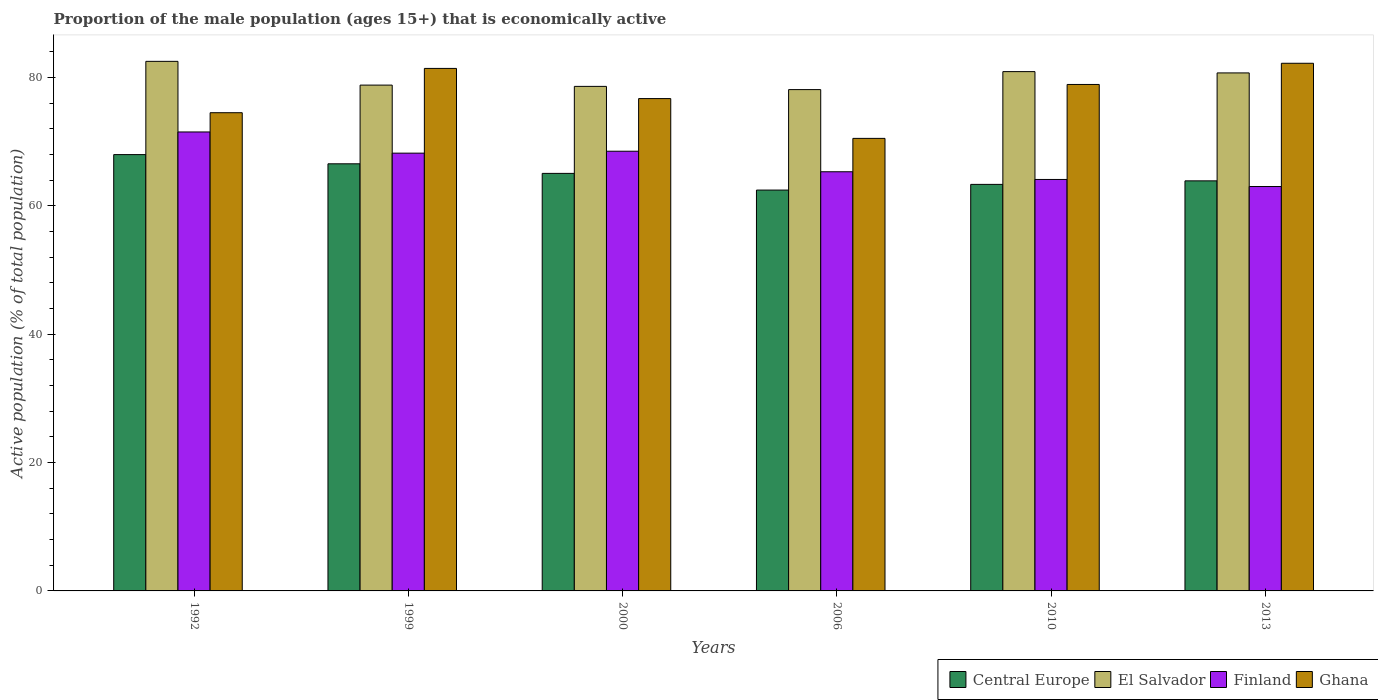How many different coloured bars are there?
Give a very brief answer. 4. How many bars are there on the 1st tick from the left?
Provide a succinct answer. 4. How many bars are there on the 5th tick from the right?
Offer a very short reply. 4. In how many cases, is the number of bars for a given year not equal to the number of legend labels?
Your answer should be very brief. 0. What is the proportion of the male population that is economically active in Central Europe in 1999?
Offer a terse response. 66.54. Across all years, what is the maximum proportion of the male population that is economically active in Finland?
Ensure brevity in your answer.  71.5. In which year was the proportion of the male population that is economically active in El Salvador maximum?
Your response must be concise. 1992. In which year was the proportion of the male population that is economically active in El Salvador minimum?
Make the answer very short. 2006. What is the total proportion of the male population that is economically active in Central Europe in the graph?
Provide a short and direct response. 389.22. What is the difference between the proportion of the male population that is economically active in El Salvador in 1992 and that in 1999?
Make the answer very short. 3.7. What is the difference between the proportion of the male population that is economically active in Finland in 2000 and the proportion of the male population that is economically active in El Salvador in 2013?
Give a very brief answer. -12.2. What is the average proportion of the male population that is economically active in Central Europe per year?
Make the answer very short. 64.87. In the year 2006, what is the difference between the proportion of the male population that is economically active in Ghana and proportion of the male population that is economically active in Finland?
Keep it short and to the point. 5.2. In how many years, is the proportion of the male population that is economically active in El Salvador greater than 12 %?
Your answer should be very brief. 6. What is the ratio of the proportion of the male population that is economically active in El Salvador in 2010 to that in 2013?
Keep it short and to the point. 1. Is the difference between the proportion of the male population that is economically active in Ghana in 1992 and 1999 greater than the difference between the proportion of the male population that is economically active in Finland in 1992 and 1999?
Make the answer very short. No. What is the difference between the highest and the second highest proportion of the male population that is economically active in El Salvador?
Your response must be concise. 1.6. What is the difference between the highest and the lowest proportion of the male population that is economically active in Central Europe?
Keep it short and to the point. 5.53. In how many years, is the proportion of the male population that is economically active in Ghana greater than the average proportion of the male population that is economically active in Ghana taken over all years?
Your response must be concise. 3. Is the sum of the proportion of the male population that is economically active in Ghana in 1999 and 2006 greater than the maximum proportion of the male population that is economically active in Central Europe across all years?
Provide a succinct answer. Yes. What does the 3rd bar from the right in 2010 represents?
Make the answer very short. El Salvador. Is it the case that in every year, the sum of the proportion of the male population that is economically active in Central Europe and proportion of the male population that is economically active in Ghana is greater than the proportion of the male population that is economically active in El Salvador?
Ensure brevity in your answer.  Yes. How many bars are there?
Your answer should be very brief. 24. Are all the bars in the graph horizontal?
Your answer should be compact. No. How many years are there in the graph?
Offer a terse response. 6. Does the graph contain any zero values?
Provide a succinct answer. No. Where does the legend appear in the graph?
Your answer should be very brief. Bottom right. How are the legend labels stacked?
Offer a terse response. Horizontal. What is the title of the graph?
Your response must be concise. Proportion of the male population (ages 15+) that is economically active. Does "Samoa" appear as one of the legend labels in the graph?
Your response must be concise. No. What is the label or title of the Y-axis?
Your answer should be compact. Active population (% of total population). What is the Active population (% of total population) of Central Europe in 1992?
Your answer should be compact. 67.97. What is the Active population (% of total population) of El Salvador in 1992?
Provide a succinct answer. 82.5. What is the Active population (% of total population) of Finland in 1992?
Offer a terse response. 71.5. What is the Active population (% of total population) of Ghana in 1992?
Give a very brief answer. 74.5. What is the Active population (% of total population) of Central Europe in 1999?
Offer a very short reply. 66.54. What is the Active population (% of total population) in El Salvador in 1999?
Keep it short and to the point. 78.8. What is the Active population (% of total population) in Finland in 1999?
Keep it short and to the point. 68.2. What is the Active population (% of total population) in Ghana in 1999?
Offer a terse response. 81.4. What is the Active population (% of total population) of Central Europe in 2000?
Provide a short and direct response. 65.05. What is the Active population (% of total population) in El Salvador in 2000?
Your answer should be very brief. 78.6. What is the Active population (% of total population) in Finland in 2000?
Your answer should be very brief. 68.5. What is the Active population (% of total population) of Ghana in 2000?
Offer a terse response. 76.7. What is the Active population (% of total population) in Central Europe in 2006?
Your response must be concise. 62.45. What is the Active population (% of total population) in El Salvador in 2006?
Keep it short and to the point. 78.1. What is the Active population (% of total population) in Finland in 2006?
Give a very brief answer. 65.3. What is the Active population (% of total population) of Ghana in 2006?
Keep it short and to the point. 70.5. What is the Active population (% of total population) of Central Europe in 2010?
Provide a succinct answer. 63.33. What is the Active population (% of total population) of El Salvador in 2010?
Make the answer very short. 80.9. What is the Active population (% of total population) in Finland in 2010?
Your answer should be compact. 64.1. What is the Active population (% of total population) of Ghana in 2010?
Your response must be concise. 78.9. What is the Active population (% of total population) in Central Europe in 2013?
Offer a terse response. 63.88. What is the Active population (% of total population) in El Salvador in 2013?
Offer a very short reply. 80.7. What is the Active population (% of total population) in Ghana in 2013?
Give a very brief answer. 82.2. Across all years, what is the maximum Active population (% of total population) of Central Europe?
Your answer should be compact. 67.97. Across all years, what is the maximum Active population (% of total population) in El Salvador?
Provide a short and direct response. 82.5. Across all years, what is the maximum Active population (% of total population) in Finland?
Provide a succinct answer. 71.5. Across all years, what is the maximum Active population (% of total population) in Ghana?
Make the answer very short. 82.2. Across all years, what is the minimum Active population (% of total population) of Central Europe?
Give a very brief answer. 62.45. Across all years, what is the minimum Active population (% of total population) of El Salvador?
Your response must be concise. 78.1. Across all years, what is the minimum Active population (% of total population) in Finland?
Offer a very short reply. 63. Across all years, what is the minimum Active population (% of total population) in Ghana?
Your answer should be very brief. 70.5. What is the total Active population (% of total population) of Central Europe in the graph?
Provide a short and direct response. 389.22. What is the total Active population (% of total population) in El Salvador in the graph?
Provide a short and direct response. 479.6. What is the total Active population (% of total population) of Finland in the graph?
Your answer should be very brief. 400.6. What is the total Active population (% of total population) of Ghana in the graph?
Provide a short and direct response. 464.2. What is the difference between the Active population (% of total population) in Central Europe in 1992 and that in 1999?
Provide a short and direct response. 1.43. What is the difference between the Active population (% of total population) in El Salvador in 1992 and that in 1999?
Provide a short and direct response. 3.7. What is the difference between the Active population (% of total population) of Ghana in 1992 and that in 1999?
Your answer should be compact. -6.9. What is the difference between the Active population (% of total population) in Central Europe in 1992 and that in 2000?
Offer a very short reply. 2.93. What is the difference between the Active population (% of total population) in El Salvador in 1992 and that in 2000?
Offer a terse response. 3.9. What is the difference between the Active population (% of total population) of Finland in 1992 and that in 2000?
Provide a short and direct response. 3. What is the difference between the Active population (% of total population) in Central Europe in 1992 and that in 2006?
Offer a terse response. 5.53. What is the difference between the Active population (% of total population) in El Salvador in 1992 and that in 2006?
Keep it short and to the point. 4.4. What is the difference between the Active population (% of total population) in Ghana in 1992 and that in 2006?
Keep it short and to the point. 4. What is the difference between the Active population (% of total population) in Central Europe in 1992 and that in 2010?
Keep it short and to the point. 4.64. What is the difference between the Active population (% of total population) in El Salvador in 1992 and that in 2010?
Make the answer very short. 1.6. What is the difference between the Active population (% of total population) in Finland in 1992 and that in 2010?
Offer a terse response. 7.4. What is the difference between the Active population (% of total population) of Ghana in 1992 and that in 2010?
Provide a short and direct response. -4.4. What is the difference between the Active population (% of total population) of Central Europe in 1992 and that in 2013?
Offer a terse response. 4.09. What is the difference between the Active population (% of total population) in El Salvador in 1992 and that in 2013?
Your response must be concise. 1.8. What is the difference between the Active population (% of total population) of Ghana in 1992 and that in 2013?
Provide a short and direct response. -7.7. What is the difference between the Active population (% of total population) of Central Europe in 1999 and that in 2000?
Keep it short and to the point. 1.49. What is the difference between the Active population (% of total population) of Finland in 1999 and that in 2000?
Give a very brief answer. -0.3. What is the difference between the Active population (% of total population) in Ghana in 1999 and that in 2000?
Ensure brevity in your answer.  4.7. What is the difference between the Active population (% of total population) of Central Europe in 1999 and that in 2006?
Make the answer very short. 4.09. What is the difference between the Active population (% of total population) in El Salvador in 1999 and that in 2006?
Provide a succinct answer. 0.7. What is the difference between the Active population (% of total population) of Finland in 1999 and that in 2006?
Ensure brevity in your answer.  2.9. What is the difference between the Active population (% of total population) in Ghana in 1999 and that in 2006?
Provide a succinct answer. 10.9. What is the difference between the Active population (% of total population) of Central Europe in 1999 and that in 2010?
Keep it short and to the point. 3.21. What is the difference between the Active population (% of total population) of El Salvador in 1999 and that in 2010?
Offer a terse response. -2.1. What is the difference between the Active population (% of total population) in Finland in 1999 and that in 2010?
Keep it short and to the point. 4.1. What is the difference between the Active population (% of total population) in Ghana in 1999 and that in 2010?
Your answer should be very brief. 2.5. What is the difference between the Active population (% of total population) of Central Europe in 1999 and that in 2013?
Keep it short and to the point. 2.66. What is the difference between the Active population (% of total population) of El Salvador in 1999 and that in 2013?
Offer a terse response. -1.9. What is the difference between the Active population (% of total population) of Ghana in 1999 and that in 2013?
Give a very brief answer. -0.8. What is the difference between the Active population (% of total population) in Central Europe in 2000 and that in 2006?
Your answer should be very brief. 2.6. What is the difference between the Active population (% of total population) of El Salvador in 2000 and that in 2006?
Your response must be concise. 0.5. What is the difference between the Active population (% of total population) in Central Europe in 2000 and that in 2010?
Your response must be concise. 1.71. What is the difference between the Active population (% of total population) of El Salvador in 2000 and that in 2010?
Provide a succinct answer. -2.3. What is the difference between the Active population (% of total population) of Central Europe in 2000 and that in 2013?
Ensure brevity in your answer.  1.16. What is the difference between the Active population (% of total population) in El Salvador in 2000 and that in 2013?
Make the answer very short. -2.1. What is the difference between the Active population (% of total population) in Ghana in 2000 and that in 2013?
Provide a succinct answer. -5.5. What is the difference between the Active population (% of total population) in Central Europe in 2006 and that in 2010?
Offer a very short reply. -0.89. What is the difference between the Active population (% of total population) in Central Europe in 2006 and that in 2013?
Ensure brevity in your answer.  -1.44. What is the difference between the Active population (% of total population) in Ghana in 2006 and that in 2013?
Offer a terse response. -11.7. What is the difference between the Active population (% of total population) of Central Europe in 2010 and that in 2013?
Make the answer very short. -0.55. What is the difference between the Active population (% of total population) of El Salvador in 2010 and that in 2013?
Give a very brief answer. 0.2. What is the difference between the Active population (% of total population) of Finland in 2010 and that in 2013?
Provide a succinct answer. 1.1. What is the difference between the Active population (% of total population) of Ghana in 2010 and that in 2013?
Offer a very short reply. -3.3. What is the difference between the Active population (% of total population) in Central Europe in 1992 and the Active population (% of total population) in El Salvador in 1999?
Offer a terse response. -10.83. What is the difference between the Active population (% of total population) in Central Europe in 1992 and the Active population (% of total population) in Finland in 1999?
Your response must be concise. -0.23. What is the difference between the Active population (% of total population) of Central Europe in 1992 and the Active population (% of total population) of Ghana in 1999?
Your answer should be very brief. -13.43. What is the difference between the Active population (% of total population) of El Salvador in 1992 and the Active population (% of total population) of Finland in 1999?
Ensure brevity in your answer.  14.3. What is the difference between the Active population (% of total population) in Finland in 1992 and the Active population (% of total population) in Ghana in 1999?
Provide a succinct answer. -9.9. What is the difference between the Active population (% of total population) of Central Europe in 1992 and the Active population (% of total population) of El Salvador in 2000?
Provide a succinct answer. -10.63. What is the difference between the Active population (% of total population) in Central Europe in 1992 and the Active population (% of total population) in Finland in 2000?
Your answer should be very brief. -0.53. What is the difference between the Active population (% of total population) of Central Europe in 1992 and the Active population (% of total population) of Ghana in 2000?
Ensure brevity in your answer.  -8.73. What is the difference between the Active population (% of total population) of Finland in 1992 and the Active population (% of total population) of Ghana in 2000?
Offer a terse response. -5.2. What is the difference between the Active population (% of total population) of Central Europe in 1992 and the Active population (% of total population) of El Salvador in 2006?
Offer a terse response. -10.13. What is the difference between the Active population (% of total population) of Central Europe in 1992 and the Active population (% of total population) of Finland in 2006?
Keep it short and to the point. 2.67. What is the difference between the Active population (% of total population) of Central Europe in 1992 and the Active population (% of total population) of Ghana in 2006?
Your answer should be compact. -2.53. What is the difference between the Active population (% of total population) in El Salvador in 1992 and the Active population (% of total population) in Finland in 2006?
Offer a very short reply. 17.2. What is the difference between the Active population (% of total population) of Finland in 1992 and the Active population (% of total population) of Ghana in 2006?
Offer a terse response. 1. What is the difference between the Active population (% of total population) of Central Europe in 1992 and the Active population (% of total population) of El Salvador in 2010?
Your answer should be very brief. -12.93. What is the difference between the Active population (% of total population) of Central Europe in 1992 and the Active population (% of total population) of Finland in 2010?
Provide a succinct answer. 3.87. What is the difference between the Active population (% of total population) in Central Europe in 1992 and the Active population (% of total population) in Ghana in 2010?
Provide a short and direct response. -10.93. What is the difference between the Active population (% of total population) in Central Europe in 1992 and the Active population (% of total population) in El Salvador in 2013?
Ensure brevity in your answer.  -12.73. What is the difference between the Active population (% of total population) of Central Europe in 1992 and the Active population (% of total population) of Finland in 2013?
Offer a very short reply. 4.97. What is the difference between the Active population (% of total population) in Central Europe in 1992 and the Active population (% of total population) in Ghana in 2013?
Offer a terse response. -14.23. What is the difference between the Active population (% of total population) in El Salvador in 1992 and the Active population (% of total population) in Finland in 2013?
Offer a terse response. 19.5. What is the difference between the Active population (% of total population) of Central Europe in 1999 and the Active population (% of total population) of El Salvador in 2000?
Give a very brief answer. -12.06. What is the difference between the Active population (% of total population) of Central Europe in 1999 and the Active population (% of total population) of Finland in 2000?
Your response must be concise. -1.96. What is the difference between the Active population (% of total population) of Central Europe in 1999 and the Active population (% of total population) of Ghana in 2000?
Offer a very short reply. -10.16. What is the difference between the Active population (% of total population) in El Salvador in 1999 and the Active population (% of total population) in Finland in 2000?
Keep it short and to the point. 10.3. What is the difference between the Active population (% of total population) in El Salvador in 1999 and the Active population (% of total population) in Ghana in 2000?
Offer a very short reply. 2.1. What is the difference between the Active population (% of total population) of Central Europe in 1999 and the Active population (% of total population) of El Salvador in 2006?
Offer a very short reply. -11.56. What is the difference between the Active population (% of total population) in Central Europe in 1999 and the Active population (% of total population) in Finland in 2006?
Keep it short and to the point. 1.24. What is the difference between the Active population (% of total population) of Central Europe in 1999 and the Active population (% of total population) of Ghana in 2006?
Provide a short and direct response. -3.96. What is the difference between the Active population (% of total population) of El Salvador in 1999 and the Active population (% of total population) of Finland in 2006?
Give a very brief answer. 13.5. What is the difference between the Active population (% of total population) in El Salvador in 1999 and the Active population (% of total population) in Ghana in 2006?
Offer a terse response. 8.3. What is the difference between the Active population (% of total population) in Central Europe in 1999 and the Active population (% of total population) in El Salvador in 2010?
Offer a very short reply. -14.36. What is the difference between the Active population (% of total population) in Central Europe in 1999 and the Active population (% of total population) in Finland in 2010?
Ensure brevity in your answer.  2.44. What is the difference between the Active population (% of total population) of Central Europe in 1999 and the Active population (% of total population) of Ghana in 2010?
Your answer should be very brief. -12.36. What is the difference between the Active population (% of total population) in Central Europe in 1999 and the Active population (% of total population) in El Salvador in 2013?
Your answer should be very brief. -14.16. What is the difference between the Active population (% of total population) in Central Europe in 1999 and the Active population (% of total population) in Finland in 2013?
Ensure brevity in your answer.  3.54. What is the difference between the Active population (% of total population) in Central Europe in 1999 and the Active population (% of total population) in Ghana in 2013?
Offer a terse response. -15.66. What is the difference between the Active population (% of total population) of Central Europe in 2000 and the Active population (% of total population) of El Salvador in 2006?
Keep it short and to the point. -13.05. What is the difference between the Active population (% of total population) in Central Europe in 2000 and the Active population (% of total population) in Finland in 2006?
Your answer should be compact. -0.25. What is the difference between the Active population (% of total population) in Central Europe in 2000 and the Active population (% of total population) in Ghana in 2006?
Your answer should be very brief. -5.45. What is the difference between the Active population (% of total population) in El Salvador in 2000 and the Active population (% of total population) in Finland in 2006?
Offer a very short reply. 13.3. What is the difference between the Active population (% of total population) of El Salvador in 2000 and the Active population (% of total population) of Ghana in 2006?
Your response must be concise. 8.1. What is the difference between the Active population (% of total population) in Finland in 2000 and the Active population (% of total population) in Ghana in 2006?
Give a very brief answer. -2. What is the difference between the Active population (% of total population) of Central Europe in 2000 and the Active population (% of total population) of El Salvador in 2010?
Give a very brief answer. -15.85. What is the difference between the Active population (% of total population) of Central Europe in 2000 and the Active population (% of total population) of Finland in 2010?
Your answer should be compact. 0.95. What is the difference between the Active population (% of total population) of Central Europe in 2000 and the Active population (% of total population) of Ghana in 2010?
Your response must be concise. -13.85. What is the difference between the Active population (% of total population) in El Salvador in 2000 and the Active population (% of total population) in Finland in 2010?
Ensure brevity in your answer.  14.5. What is the difference between the Active population (% of total population) of El Salvador in 2000 and the Active population (% of total population) of Ghana in 2010?
Ensure brevity in your answer.  -0.3. What is the difference between the Active population (% of total population) in Central Europe in 2000 and the Active population (% of total population) in El Salvador in 2013?
Ensure brevity in your answer.  -15.65. What is the difference between the Active population (% of total population) in Central Europe in 2000 and the Active population (% of total population) in Finland in 2013?
Provide a short and direct response. 2.05. What is the difference between the Active population (% of total population) in Central Europe in 2000 and the Active population (% of total population) in Ghana in 2013?
Keep it short and to the point. -17.15. What is the difference between the Active population (% of total population) of El Salvador in 2000 and the Active population (% of total population) of Finland in 2013?
Give a very brief answer. 15.6. What is the difference between the Active population (% of total population) of Finland in 2000 and the Active population (% of total population) of Ghana in 2013?
Offer a terse response. -13.7. What is the difference between the Active population (% of total population) of Central Europe in 2006 and the Active population (% of total population) of El Salvador in 2010?
Your answer should be very brief. -18.45. What is the difference between the Active population (% of total population) in Central Europe in 2006 and the Active population (% of total population) in Finland in 2010?
Offer a very short reply. -1.65. What is the difference between the Active population (% of total population) in Central Europe in 2006 and the Active population (% of total population) in Ghana in 2010?
Offer a very short reply. -16.45. What is the difference between the Active population (% of total population) of El Salvador in 2006 and the Active population (% of total population) of Finland in 2010?
Your answer should be compact. 14. What is the difference between the Active population (% of total population) of Central Europe in 2006 and the Active population (% of total population) of El Salvador in 2013?
Offer a very short reply. -18.25. What is the difference between the Active population (% of total population) in Central Europe in 2006 and the Active population (% of total population) in Finland in 2013?
Your answer should be compact. -0.55. What is the difference between the Active population (% of total population) in Central Europe in 2006 and the Active population (% of total population) in Ghana in 2013?
Make the answer very short. -19.75. What is the difference between the Active population (% of total population) of El Salvador in 2006 and the Active population (% of total population) of Finland in 2013?
Make the answer very short. 15.1. What is the difference between the Active population (% of total population) of El Salvador in 2006 and the Active population (% of total population) of Ghana in 2013?
Your answer should be very brief. -4.1. What is the difference between the Active population (% of total population) in Finland in 2006 and the Active population (% of total population) in Ghana in 2013?
Provide a succinct answer. -16.9. What is the difference between the Active population (% of total population) in Central Europe in 2010 and the Active population (% of total population) in El Salvador in 2013?
Provide a short and direct response. -17.37. What is the difference between the Active population (% of total population) of Central Europe in 2010 and the Active population (% of total population) of Finland in 2013?
Your answer should be very brief. 0.33. What is the difference between the Active population (% of total population) in Central Europe in 2010 and the Active population (% of total population) in Ghana in 2013?
Provide a short and direct response. -18.87. What is the difference between the Active population (% of total population) of El Salvador in 2010 and the Active population (% of total population) of Finland in 2013?
Provide a succinct answer. 17.9. What is the difference between the Active population (% of total population) in Finland in 2010 and the Active population (% of total population) in Ghana in 2013?
Provide a succinct answer. -18.1. What is the average Active population (% of total population) of Central Europe per year?
Make the answer very short. 64.87. What is the average Active population (% of total population) of El Salvador per year?
Your answer should be very brief. 79.93. What is the average Active population (% of total population) of Finland per year?
Keep it short and to the point. 66.77. What is the average Active population (% of total population) of Ghana per year?
Provide a short and direct response. 77.37. In the year 1992, what is the difference between the Active population (% of total population) of Central Europe and Active population (% of total population) of El Salvador?
Provide a succinct answer. -14.53. In the year 1992, what is the difference between the Active population (% of total population) in Central Europe and Active population (% of total population) in Finland?
Provide a succinct answer. -3.53. In the year 1992, what is the difference between the Active population (% of total population) of Central Europe and Active population (% of total population) of Ghana?
Ensure brevity in your answer.  -6.53. In the year 1992, what is the difference between the Active population (% of total population) in El Salvador and Active population (% of total population) in Ghana?
Offer a terse response. 8. In the year 1992, what is the difference between the Active population (% of total population) of Finland and Active population (% of total population) of Ghana?
Ensure brevity in your answer.  -3. In the year 1999, what is the difference between the Active population (% of total population) of Central Europe and Active population (% of total population) of El Salvador?
Provide a short and direct response. -12.26. In the year 1999, what is the difference between the Active population (% of total population) in Central Europe and Active population (% of total population) in Finland?
Offer a terse response. -1.66. In the year 1999, what is the difference between the Active population (% of total population) of Central Europe and Active population (% of total population) of Ghana?
Your answer should be very brief. -14.86. In the year 1999, what is the difference between the Active population (% of total population) of El Salvador and Active population (% of total population) of Finland?
Keep it short and to the point. 10.6. In the year 2000, what is the difference between the Active population (% of total population) in Central Europe and Active population (% of total population) in El Salvador?
Offer a terse response. -13.55. In the year 2000, what is the difference between the Active population (% of total population) in Central Europe and Active population (% of total population) in Finland?
Your answer should be very brief. -3.45. In the year 2000, what is the difference between the Active population (% of total population) in Central Europe and Active population (% of total population) in Ghana?
Provide a short and direct response. -11.65. In the year 2000, what is the difference between the Active population (% of total population) of El Salvador and Active population (% of total population) of Finland?
Provide a short and direct response. 10.1. In the year 2006, what is the difference between the Active population (% of total population) in Central Europe and Active population (% of total population) in El Salvador?
Make the answer very short. -15.65. In the year 2006, what is the difference between the Active population (% of total population) of Central Europe and Active population (% of total population) of Finland?
Offer a terse response. -2.85. In the year 2006, what is the difference between the Active population (% of total population) in Central Europe and Active population (% of total population) in Ghana?
Offer a very short reply. -8.05. In the year 2006, what is the difference between the Active population (% of total population) of El Salvador and Active population (% of total population) of Finland?
Give a very brief answer. 12.8. In the year 2006, what is the difference between the Active population (% of total population) in El Salvador and Active population (% of total population) in Ghana?
Offer a terse response. 7.6. In the year 2006, what is the difference between the Active population (% of total population) of Finland and Active population (% of total population) of Ghana?
Your response must be concise. -5.2. In the year 2010, what is the difference between the Active population (% of total population) in Central Europe and Active population (% of total population) in El Salvador?
Your response must be concise. -17.57. In the year 2010, what is the difference between the Active population (% of total population) of Central Europe and Active population (% of total population) of Finland?
Ensure brevity in your answer.  -0.77. In the year 2010, what is the difference between the Active population (% of total population) of Central Europe and Active population (% of total population) of Ghana?
Ensure brevity in your answer.  -15.57. In the year 2010, what is the difference between the Active population (% of total population) of El Salvador and Active population (% of total population) of Finland?
Give a very brief answer. 16.8. In the year 2010, what is the difference between the Active population (% of total population) of El Salvador and Active population (% of total population) of Ghana?
Ensure brevity in your answer.  2. In the year 2010, what is the difference between the Active population (% of total population) of Finland and Active population (% of total population) of Ghana?
Provide a short and direct response. -14.8. In the year 2013, what is the difference between the Active population (% of total population) in Central Europe and Active population (% of total population) in El Salvador?
Give a very brief answer. -16.82. In the year 2013, what is the difference between the Active population (% of total population) in Central Europe and Active population (% of total population) in Finland?
Your answer should be very brief. 0.88. In the year 2013, what is the difference between the Active population (% of total population) in Central Europe and Active population (% of total population) in Ghana?
Keep it short and to the point. -18.32. In the year 2013, what is the difference between the Active population (% of total population) of El Salvador and Active population (% of total population) of Finland?
Your answer should be compact. 17.7. In the year 2013, what is the difference between the Active population (% of total population) in Finland and Active population (% of total population) in Ghana?
Keep it short and to the point. -19.2. What is the ratio of the Active population (% of total population) of Central Europe in 1992 to that in 1999?
Ensure brevity in your answer.  1.02. What is the ratio of the Active population (% of total population) of El Salvador in 1992 to that in 1999?
Provide a succinct answer. 1.05. What is the ratio of the Active population (% of total population) of Finland in 1992 to that in 1999?
Give a very brief answer. 1.05. What is the ratio of the Active population (% of total population) in Ghana in 1992 to that in 1999?
Make the answer very short. 0.92. What is the ratio of the Active population (% of total population) in Central Europe in 1992 to that in 2000?
Make the answer very short. 1.04. What is the ratio of the Active population (% of total population) in El Salvador in 1992 to that in 2000?
Your answer should be very brief. 1.05. What is the ratio of the Active population (% of total population) in Finland in 1992 to that in 2000?
Provide a succinct answer. 1.04. What is the ratio of the Active population (% of total population) in Ghana in 1992 to that in 2000?
Provide a succinct answer. 0.97. What is the ratio of the Active population (% of total population) of Central Europe in 1992 to that in 2006?
Your answer should be compact. 1.09. What is the ratio of the Active population (% of total population) in El Salvador in 1992 to that in 2006?
Provide a succinct answer. 1.06. What is the ratio of the Active population (% of total population) in Finland in 1992 to that in 2006?
Your answer should be very brief. 1.09. What is the ratio of the Active population (% of total population) of Ghana in 1992 to that in 2006?
Make the answer very short. 1.06. What is the ratio of the Active population (% of total population) of Central Europe in 1992 to that in 2010?
Your answer should be very brief. 1.07. What is the ratio of the Active population (% of total population) of El Salvador in 1992 to that in 2010?
Your response must be concise. 1.02. What is the ratio of the Active population (% of total population) of Finland in 1992 to that in 2010?
Offer a terse response. 1.12. What is the ratio of the Active population (% of total population) of Ghana in 1992 to that in 2010?
Your answer should be compact. 0.94. What is the ratio of the Active population (% of total population) of Central Europe in 1992 to that in 2013?
Keep it short and to the point. 1.06. What is the ratio of the Active population (% of total population) in El Salvador in 1992 to that in 2013?
Offer a terse response. 1.02. What is the ratio of the Active population (% of total population) in Finland in 1992 to that in 2013?
Offer a terse response. 1.13. What is the ratio of the Active population (% of total population) in Ghana in 1992 to that in 2013?
Offer a very short reply. 0.91. What is the ratio of the Active population (% of total population) of Central Europe in 1999 to that in 2000?
Make the answer very short. 1.02. What is the ratio of the Active population (% of total population) in Finland in 1999 to that in 2000?
Your answer should be compact. 1. What is the ratio of the Active population (% of total population) of Ghana in 1999 to that in 2000?
Give a very brief answer. 1.06. What is the ratio of the Active population (% of total population) in Central Europe in 1999 to that in 2006?
Give a very brief answer. 1.07. What is the ratio of the Active population (% of total population) of Finland in 1999 to that in 2006?
Give a very brief answer. 1.04. What is the ratio of the Active population (% of total population) in Ghana in 1999 to that in 2006?
Provide a short and direct response. 1.15. What is the ratio of the Active population (% of total population) in Central Europe in 1999 to that in 2010?
Your answer should be very brief. 1.05. What is the ratio of the Active population (% of total population) in Finland in 1999 to that in 2010?
Your answer should be compact. 1.06. What is the ratio of the Active population (% of total population) of Ghana in 1999 to that in 2010?
Your answer should be very brief. 1.03. What is the ratio of the Active population (% of total population) of Central Europe in 1999 to that in 2013?
Provide a short and direct response. 1.04. What is the ratio of the Active population (% of total population) of El Salvador in 1999 to that in 2013?
Make the answer very short. 0.98. What is the ratio of the Active population (% of total population) of Finland in 1999 to that in 2013?
Ensure brevity in your answer.  1.08. What is the ratio of the Active population (% of total population) of Ghana in 1999 to that in 2013?
Provide a succinct answer. 0.99. What is the ratio of the Active population (% of total population) in Central Europe in 2000 to that in 2006?
Your answer should be very brief. 1.04. What is the ratio of the Active population (% of total population) in El Salvador in 2000 to that in 2006?
Offer a very short reply. 1.01. What is the ratio of the Active population (% of total population) of Finland in 2000 to that in 2006?
Offer a terse response. 1.05. What is the ratio of the Active population (% of total population) of Ghana in 2000 to that in 2006?
Give a very brief answer. 1.09. What is the ratio of the Active population (% of total population) in Central Europe in 2000 to that in 2010?
Keep it short and to the point. 1.03. What is the ratio of the Active population (% of total population) of El Salvador in 2000 to that in 2010?
Keep it short and to the point. 0.97. What is the ratio of the Active population (% of total population) in Finland in 2000 to that in 2010?
Give a very brief answer. 1.07. What is the ratio of the Active population (% of total population) of Ghana in 2000 to that in 2010?
Ensure brevity in your answer.  0.97. What is the ratio of the Active population (% of total population) in Central Europe in 2000 to that in 2013?
Keep it short and to the point. 1.02. What is the ratio of the Active population (% of total population) of Finland in 2000 to that in 2013?
Your answer should be very brief. 1.09. What is the ratio of the Active population (% of total population) of Ghana in 2000 to that in 2013?
Your response must be concise. 0.93. What is the ratio of the Active population (% of total population) in El Salvador in 2006 to that in 2010?
Your answer should be compact. 0.97. What is the ratio of the Active population (% of total population) in Finland in 2006 to that in 2010?
Your answer should be compact. 1.02. What is the ratio of the Active population (% of total population) in Ghana in 2006 to that in 2010?
Your answer should be very brief. 0.89. What is the ratio of the Active population (% of total population) of Central Europe in 2006 to that in 2013?
Ensure brevity in your answer.  0.98. What is the ratio of the Active population (% of total population) in El Salvador in 2006 to that in 2013?
Provide a short and direct response. 0.97. What is the ratio of the Active population (% of total population) of Finland in 2006 to that in 2013?
Your response must be concise. 1.04. What is the ratio of the Active population (% of total population) in Ghana in 2006 to that in 2013?
Offer a terse response. 0.86. What is the ratio of the Active population (% of total population) in El Salvador in 2010 to that in 2013?
Offer a very short reply. 1. What is the ratio of the Active population (% of total population) of Finland in 2010 to that in 2013?
Ensure brevity in your answer.  1.02. What is the ratio of the Active population (% of total population) in Ghana in 2010 to that in 2013?
Make the answer very short. 0.96. What is the difference between the highest and the second highest Active population (% of total population) of Central Europe?
Ensure brevity in your answer.  1.43. What is the difference between the highest and the second highest Active population (% of total population) of El Salvador?
Your answer should be compact. 1.6. What is the difference between the highest and the second highest Active population (% of total population) of Finland?
Provide a short and direct response. 3. What is the difference between the highest and the lowest Active population (% of total population) in Central Europe?
Offer a very short reply. 5.53. 